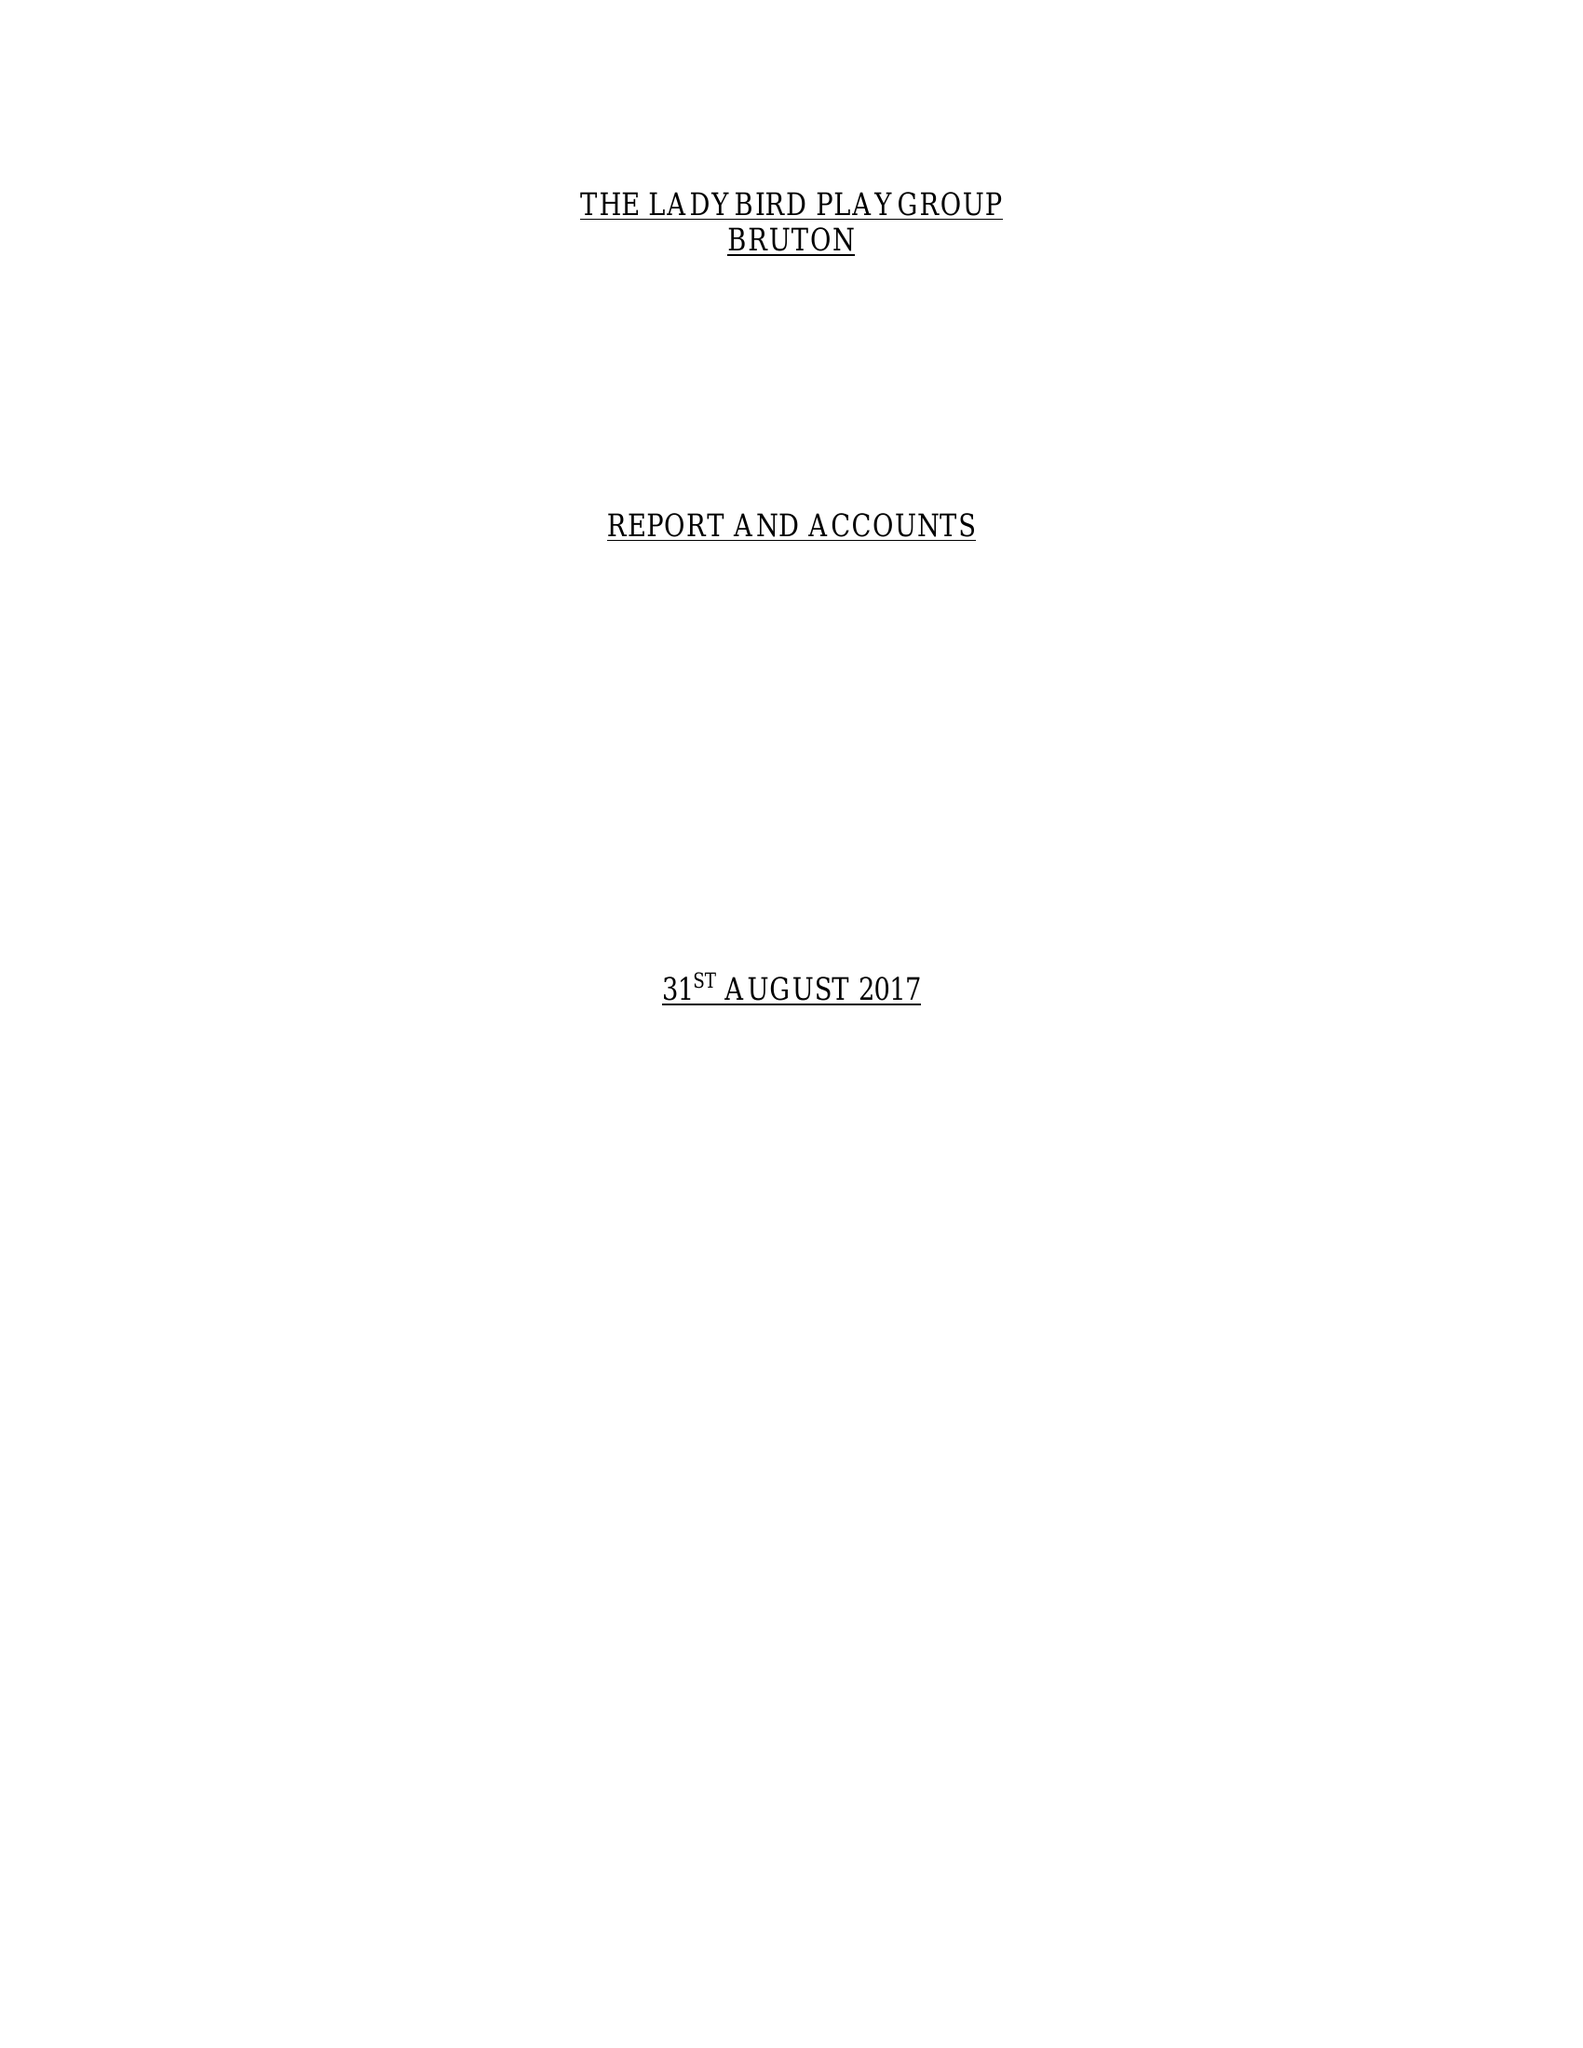What is the value for the report_date?
Answer the question using a single word or phrase. 2017-08-31 